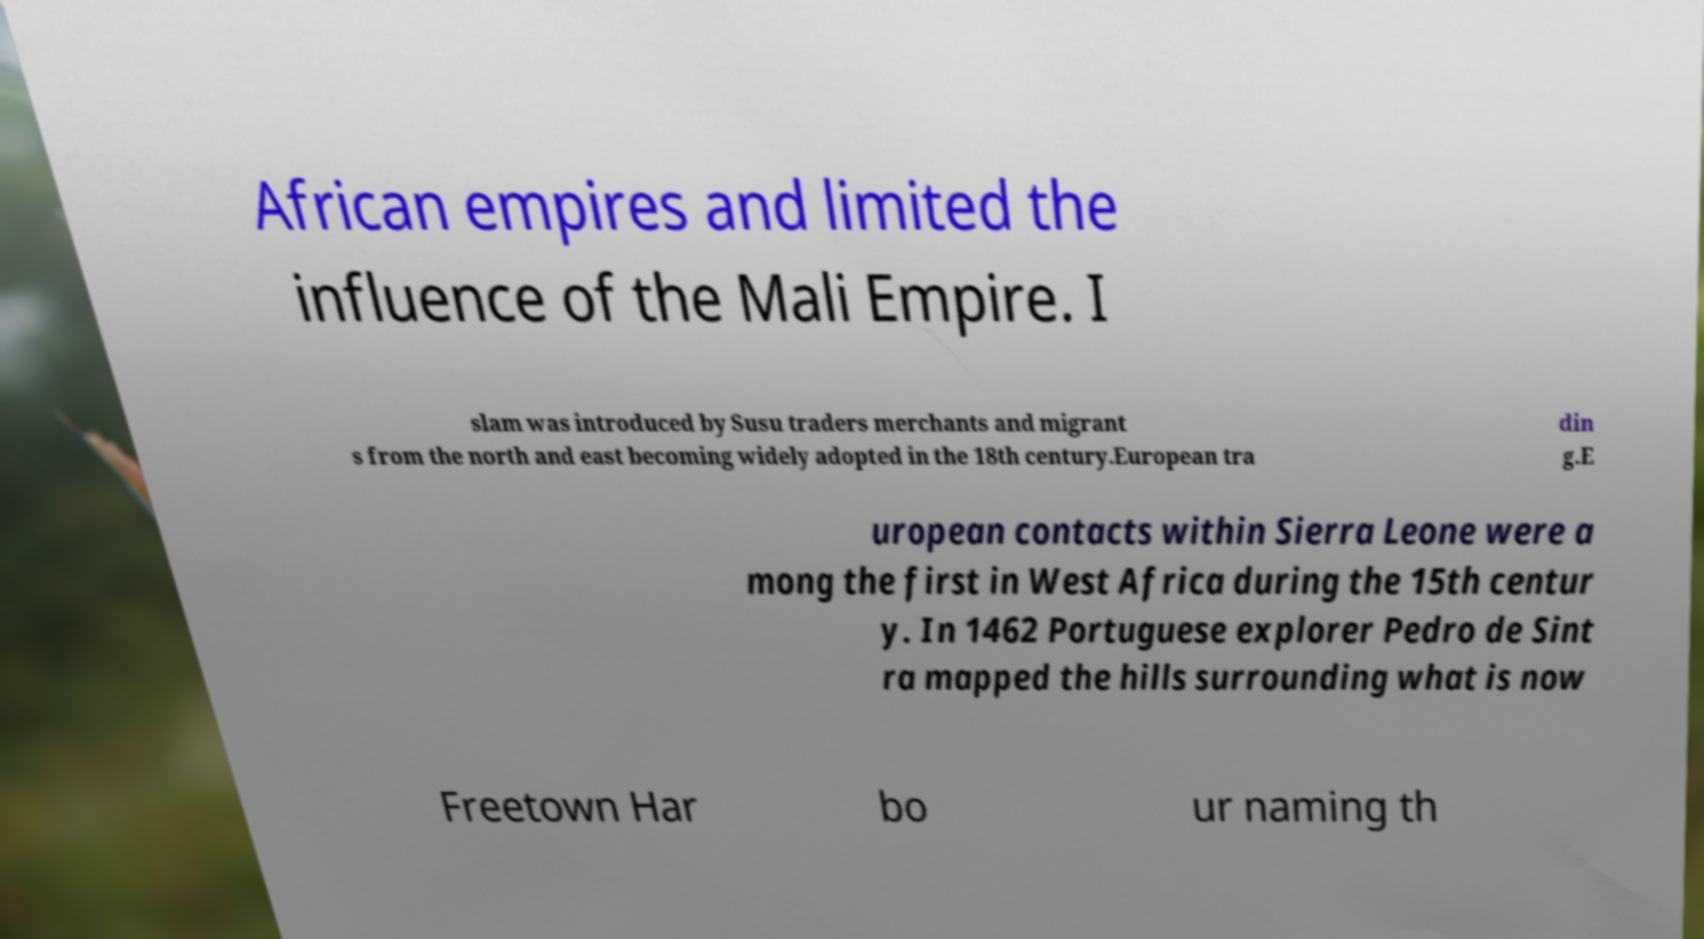I need the written content from this picture converted into text. Can you do that? African empires and limited the influence of the Mali Empire. I slam was introduced by Susu traders merchants and migrant s from the north and east becoming widely adopted in the 18th century.European tra din g.E uropean contacts within Sierra Leone were a mong the first in West Africa during the 15th centur y. In 1462 Portuguese explorer Pedro de Sint ra mapped the hills surrounding what is now Freetown Har bo ur naming th 